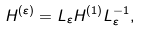<formula> <loc_0><loc_0><loc_500><loc_500>H ^ { ( \varepsilon ) } = L _ { \varepsilon } H ^ { ( 1 ) } L _ { \varepsilon } ^ { - 1 } ,</formula> 